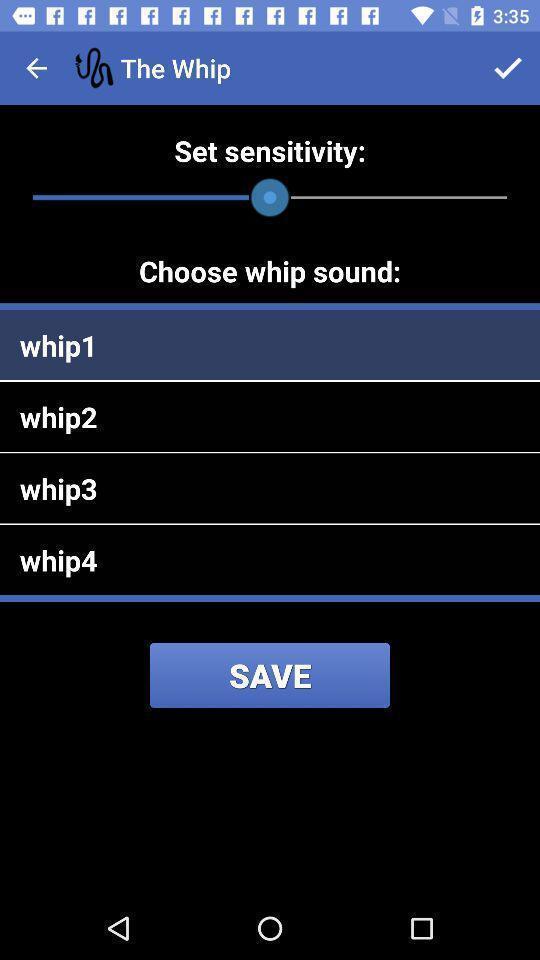Describe the key features of this screenshot. Sound bar of whip. 